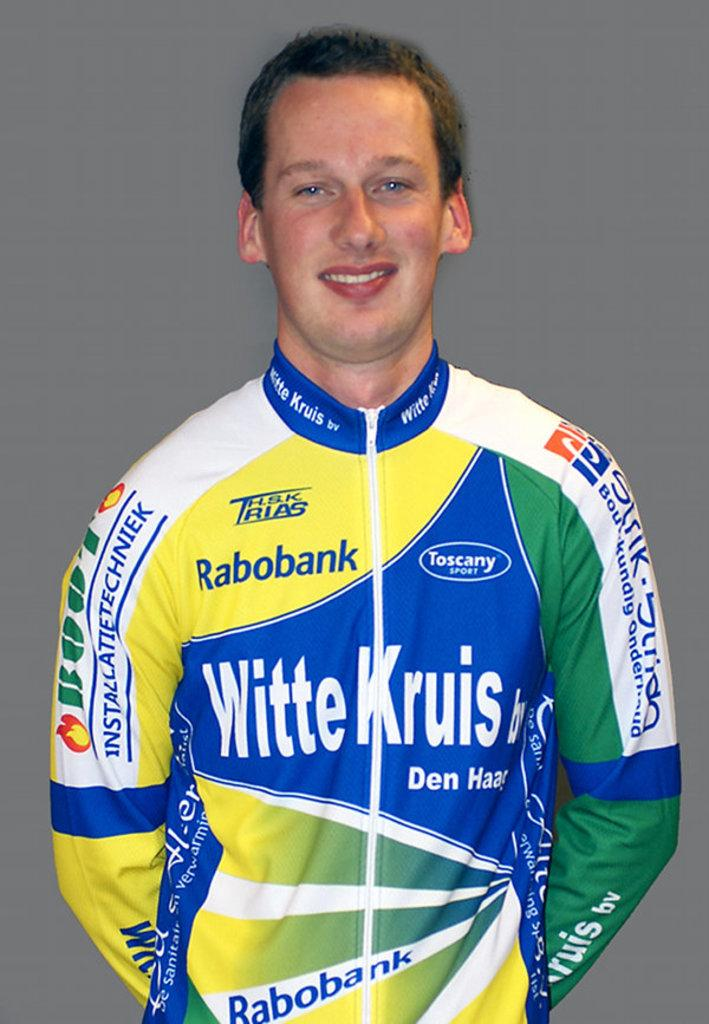Provide a one-sentence caption for the provided image. smiling man in racing suit with sponsors such as rabobank, witte kruis, and toscany sport. 